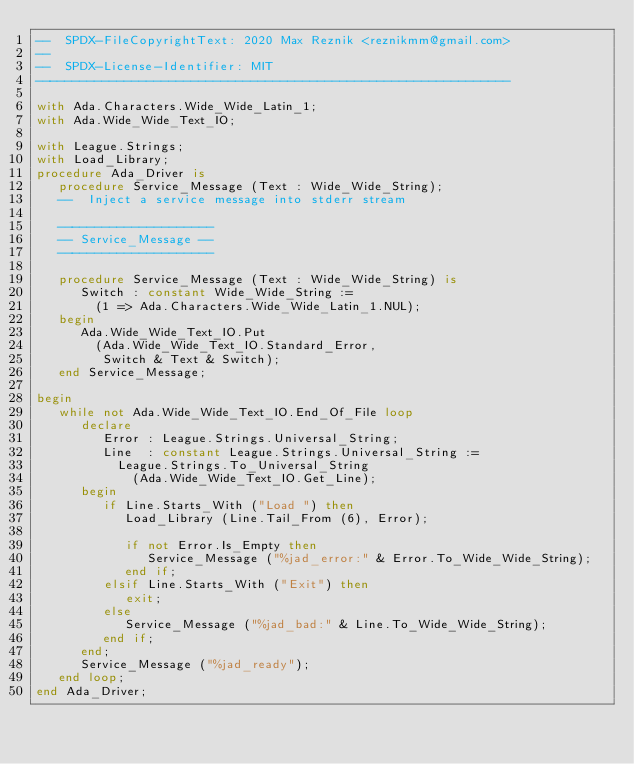Convert code to text. <code><loc_0><loc_0><loc_500><loc_500><_Ada_>--  SPDX-FileCopyrightText: 2020 Max Reznik <reznikmm@gmail.com>
--
--  SPDX-License-Identifier: MIT
----------------------------------------------------------------

with Ada.Characters.Wide_Wide_Latin_1;
with Ada.Wide_Wide_Text_IO;

with League.Strings;
with Load_Library;
procedure Ada_Driver is
   procedure Service_Message (Text : Wide_Wide_String);
   --  Inject a service message into stderr stream

   ---------------------
   -- Service_Message --
   ---------------------

   procedure Service_Message (Text : Wide_Wide_String) is
      Switch : constant Wide_Wide_String :=
        (1 => Ada.Characters.Wide_Wide_Latin_1.NUL);
   begin
      Ada.Wide_Wide_Text_IO.Put
        (Ada.Wide_Wide_Text_IO.Standard_Error,
         Switch & Text & Switch);
   end Service_Message;

begin
   while not Ada.Wide_Wide_Text_IO.End_Of_File loop
      declare
         Error : League.Strings.Universal_String;
         Line  : constant League.Strings.Universal_String :=
           League.Strings.To_Universal_String
             (Ada.Wide_Wide_Text_IO.Get_Line);
      begin
         if Line.Starts_With ("Load ") then
            Load_Library (Line.Tail_From (6), Error);

            if not Error.Is_Empty then
               Service_Message ("%jad_error:" & Error.To_Wide_Wide_String);
            end if;
         elsif Line.Starts_With ("Exit") then
            exit;
         else
            Service_Message ("%jad_bad:" & Line.To_Wide_Wide_String);
         end if;
      end;
      Service_Message ("%jad_ready");
   end loop;
end Ada_Driver;
</code> 